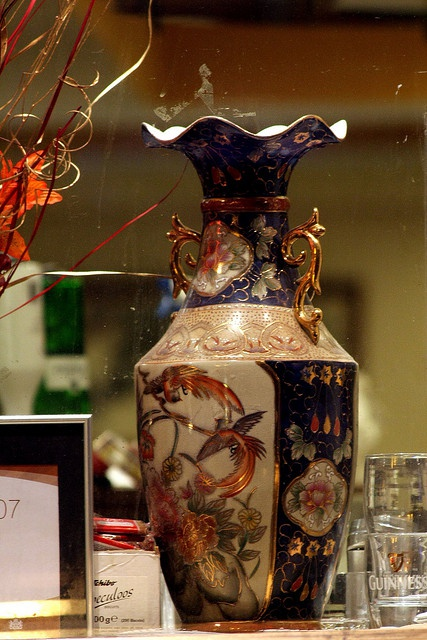Describe the objects in this image and their specific colors. I can see vase in darkgreen, black, maroon, and gray tones and cup in darkgreen, tan, and gray tones in this image. 